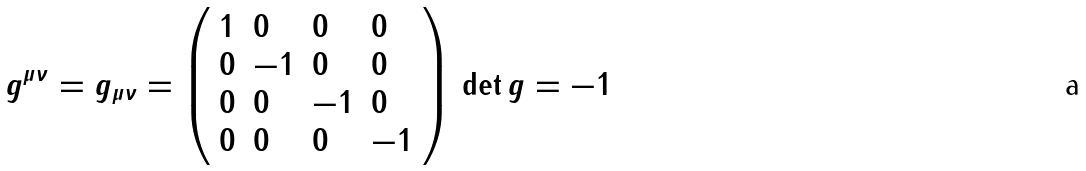<formula> <loc_0><loc_0><loc_500><loc_500>g ^ { \mu \nu } = g _ { \mu \nu } = \left ( \begin{array} { l l l l } 1 & 0 & 0 & 0 \\ 0 & - 1 & 0 & 0 \\ 0 & 0 & - 1 & 0 \\ 0 & 0 & 0 & - 1 \end{array} \right ) \, \det g = - 1</formula> 